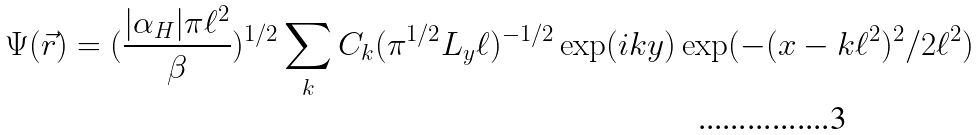Convert formula to latex. <formula><loc_0><loc_0><loc_500><loc_500>\Psi ( \vec { r } ) = ( \frac { | \alpha _ { H } | \pi \ell ^ { 2 } } { \beta } ) ^ { 1 / 2 } \sum _ { k } C _ { k } ( \pi ^ { 1 / 2 } L _ { y } \ell ) ^ { - 1 / 2 } \exp ( i k y ) \exp ( - ( x - k \ell ^ { 2 } ) ^ { 2 } / 2 \ell ^ { 2 } )</formula> 